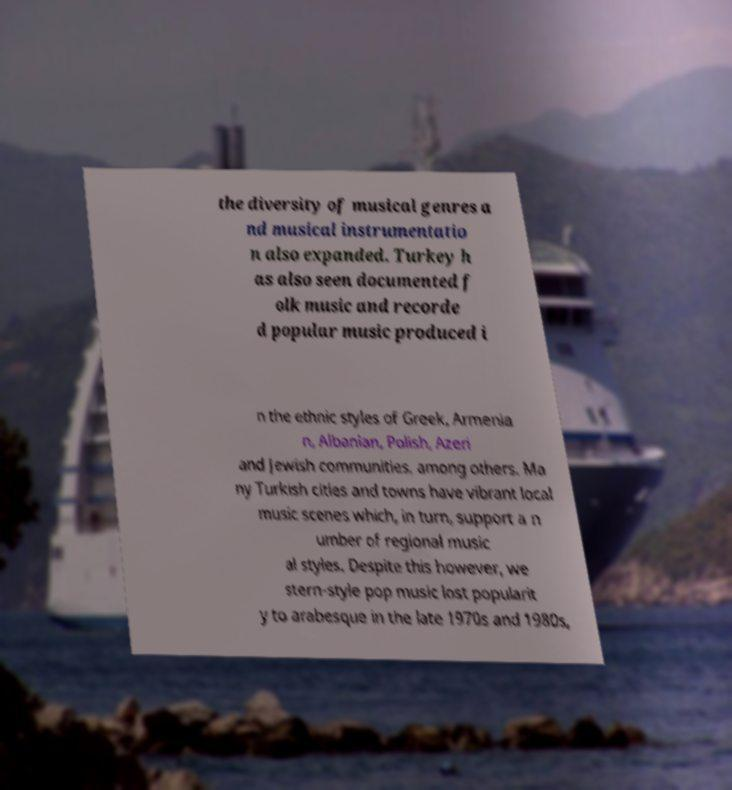What messages or text are displayed in this image? I need them in a readable, typed format. the diversity of musical genres a nd musical instrumentatio n also expanded. Turkey h as also seen documented f olk music and recorde d popular music produced i n the ethnic styles of Greek, Armenia n, Albanian, Polish, Azeri and Jewish communities, among others. Ma ny Turkish cities and towns have vibrant local music scenes which, in turn, support a n umber of regional music al styles. Despite this however, we stern-style pop music lost popularit y to arabesque in the late 1970s and 1980s, 